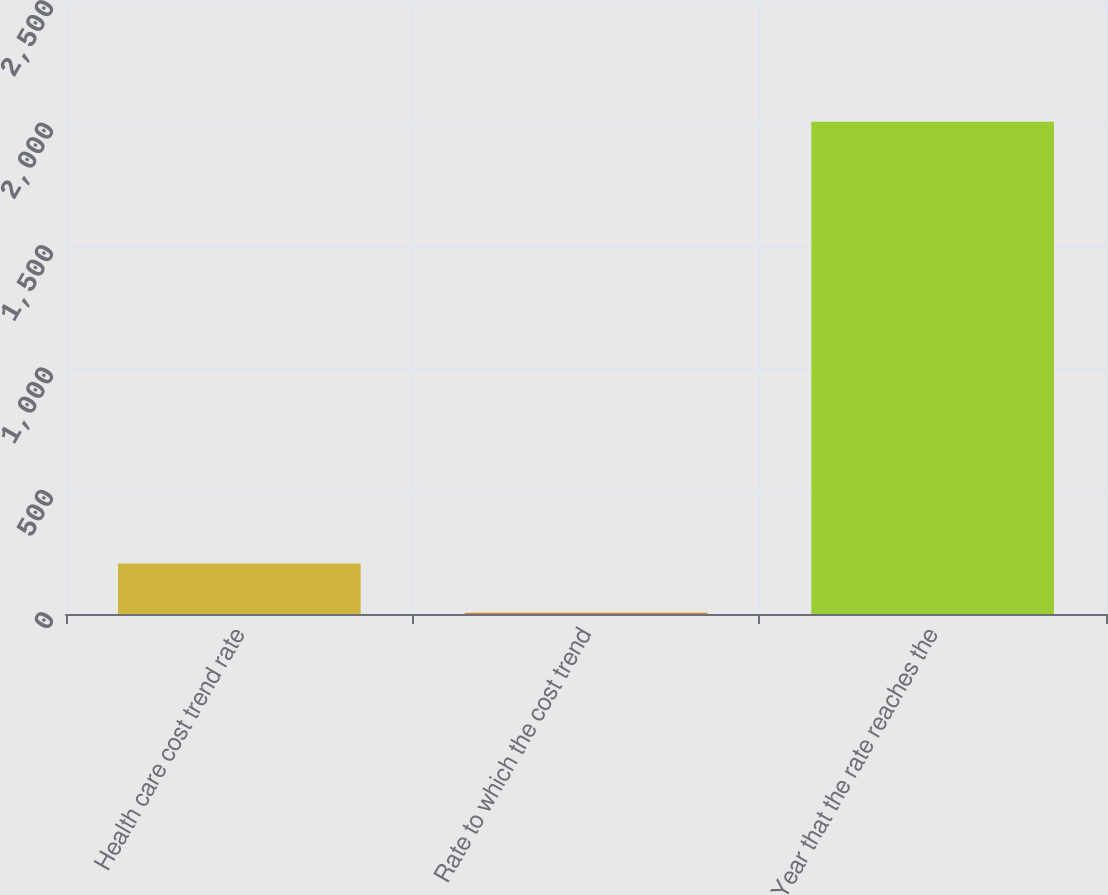<chart> <loc_0><loc_0><loc_500><loc_500><bar_chart><fcel>Health care cost trend rate<fcel>Rate to which the cost trend<fcel>Year that the rate reaches the<nl><fcel>206.05<fcel>5.5<fcel>2011<nl></chart> 